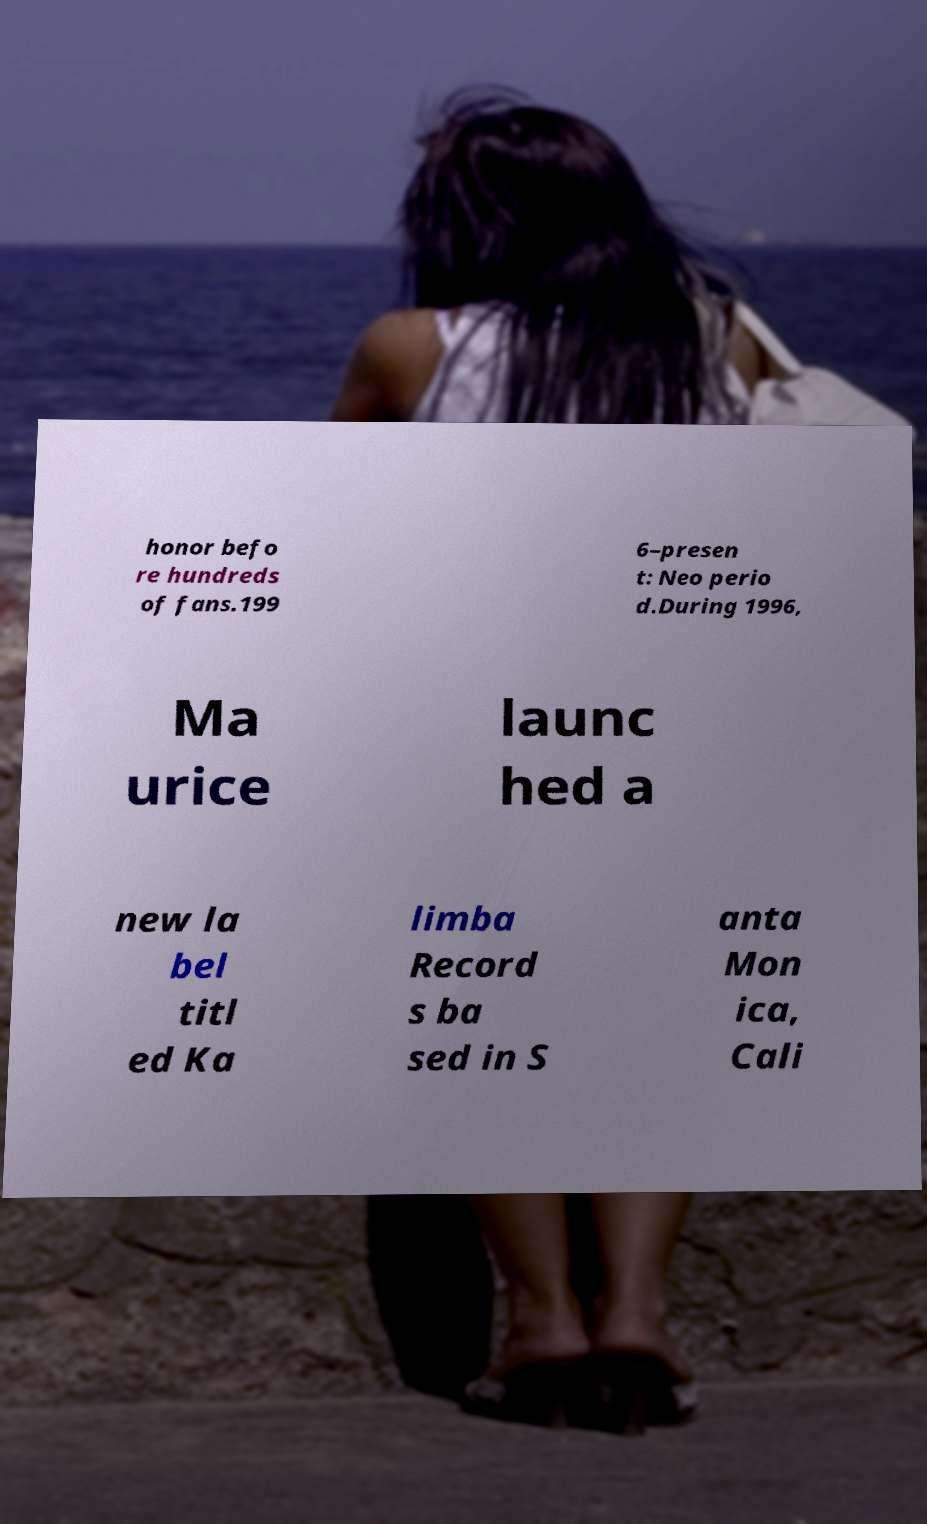Please read and relay the text visible in this image. What does it say? honor befo re hundreds of fans.199 6–presen t: Neo perio d.During 1996, Ma urice launc hed a new la bel titl ed Ka limba Record s ba sed in S anta Mon ica, Cali 